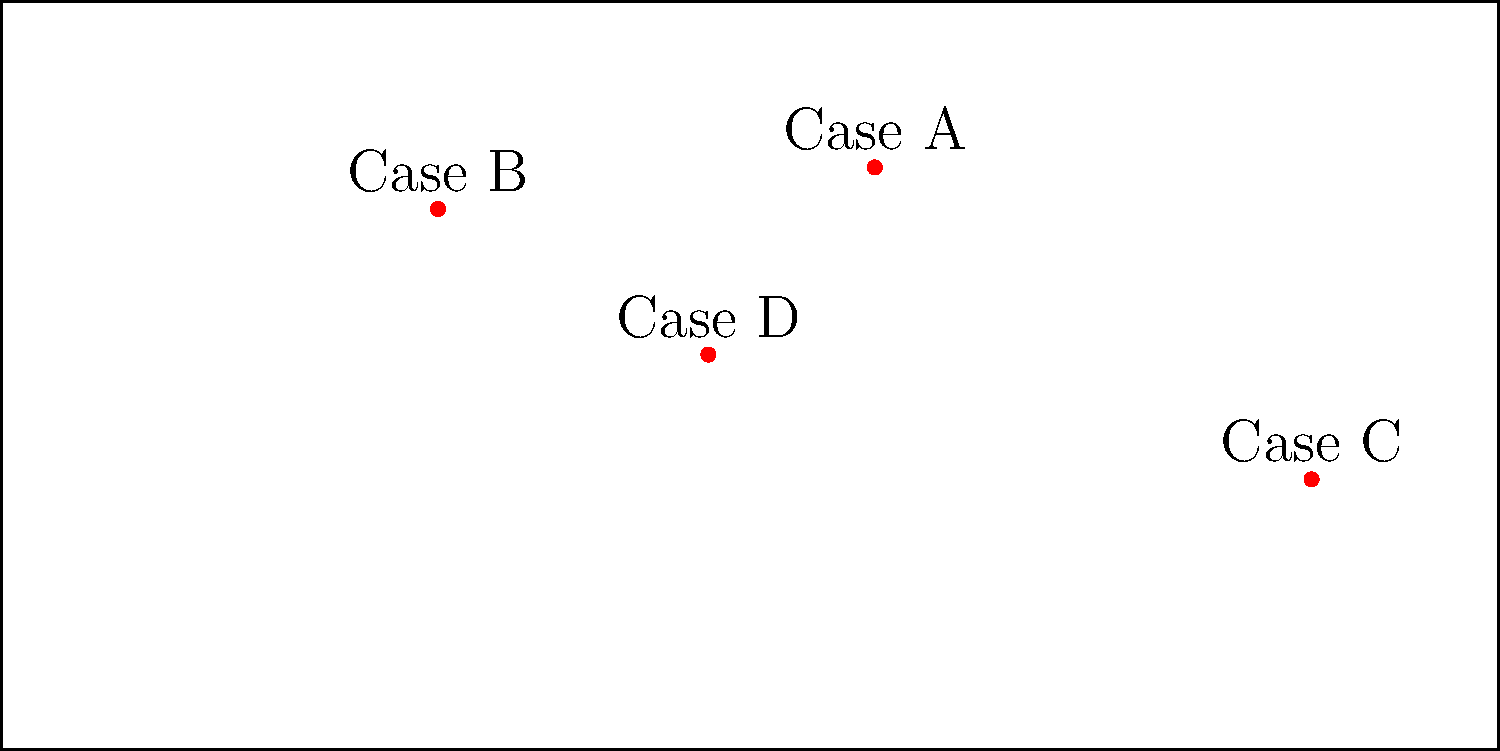Based on the world map coordinate system shown, which international human rights case location is closest to the equator (0° latitude)? Provide your answer in the format "Case X". To determine which case location is closest to the equator (0° latitude), we need to follow these steps:

1. Identify the latitude coordinates of each case:
   Case A: approximately 50° N
   Case B: approximately 40° N
   Case C: approximately 25° S
   Case D: approximately 5° N

2. Calculate the absolute difference between each case's latitude and the equator (0°):
   Case A: |50 - 0| = 50°
   Case B: |40 - 0| = 40°
   Case C: |(-25) - 0| = 25°
   Case D: |5 - 0| = 5°

3. Compare the differences to find the smallest:
   Case D has the smallest difference of 5°.

Therefore, Case D is closest to the equator.
Answer: Case D 